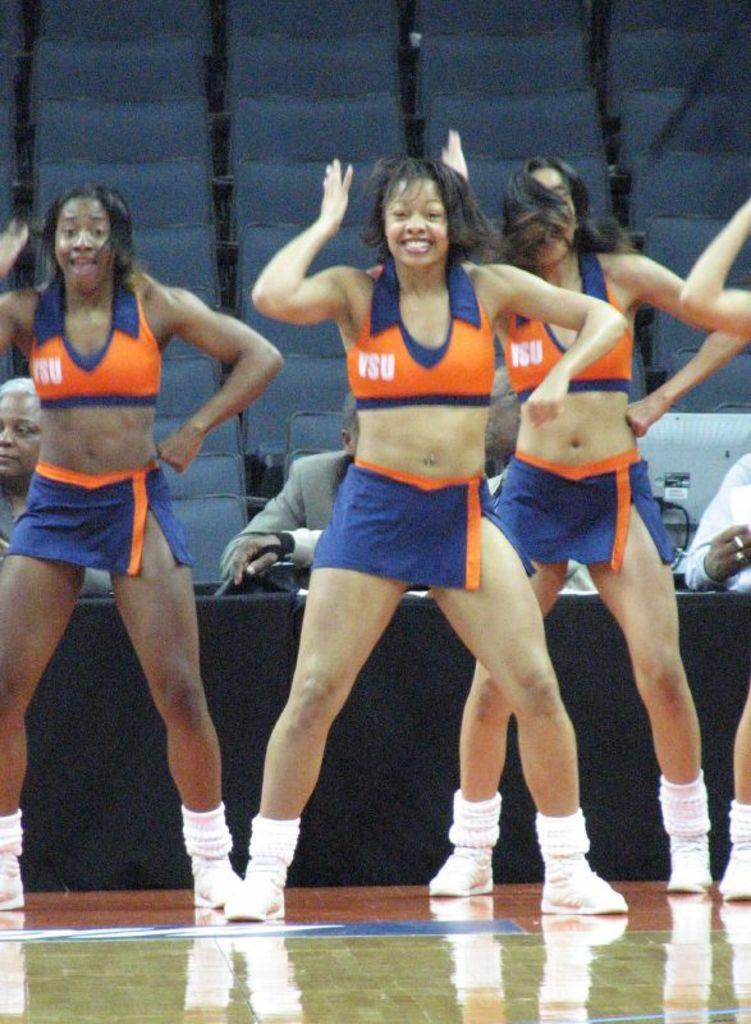<image>
Create a compact narrative representing the image presented. Three cheerleaders in blue and orange uniforms with VSU on their shirts 